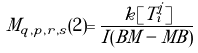<formula> <loc_0><loc_0><loc_500><loc_500>M _ { q , p , r , s } ( 2 ) = \frac { k [ T _ { i } ^ { j } ] } { I ( B M - M B ) }</formula> 